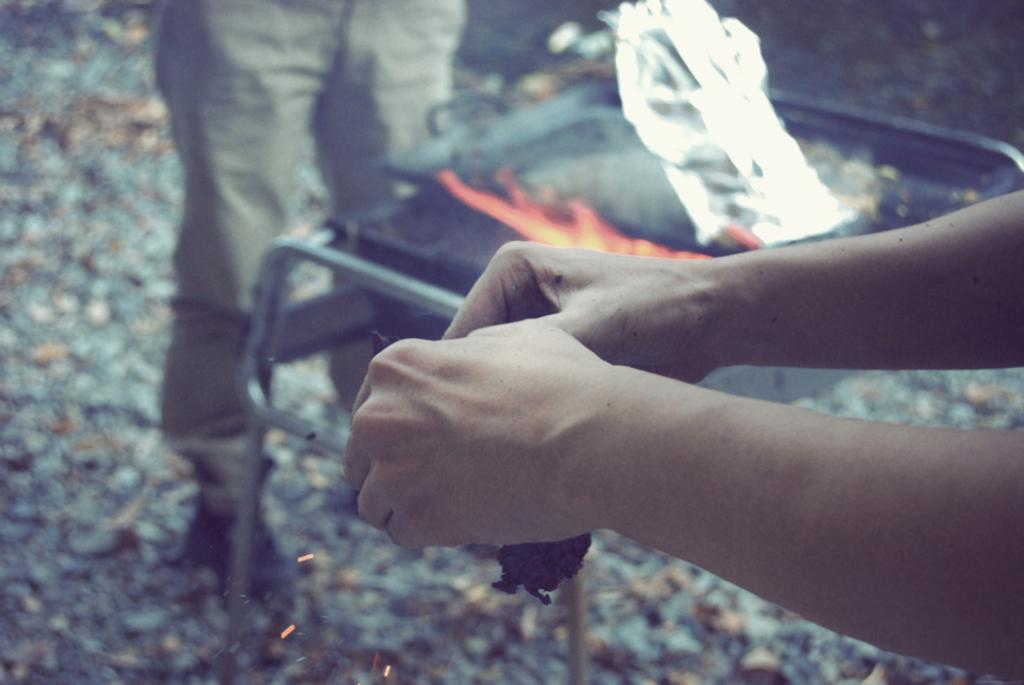What is being held by the hands in the foreground of the image? The object being held by the hands in the foreground of the image is not specified. What type of appliance or equipment can be seen in the image? There is a stove-like object in the image. What material is present in the image? There is a silver sheet in the image. Whose legs are visible in the image? The legs of a person are visible in the image. What type of sofa can be seen on the hill in the image? There is no sofa or hill present in the image. What is the price of the silver sheet in the image? The price of the silver sheet in the image is not mentioned, as the image does not provide any information about its cost. 